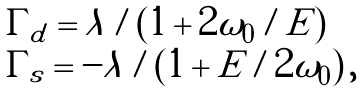<formula> <loc_0><loc_0><loc_500><loc_500>\begin{array} { l } \Gamma _ { d } = \lambda / ( 1 + 2 \omega _ { 0 } / E ) \\ \Gamma _ { s } = - \lambda / ( 1 + E / 2 \omega _ { 0 } ) \, , \end{array}</formula> 